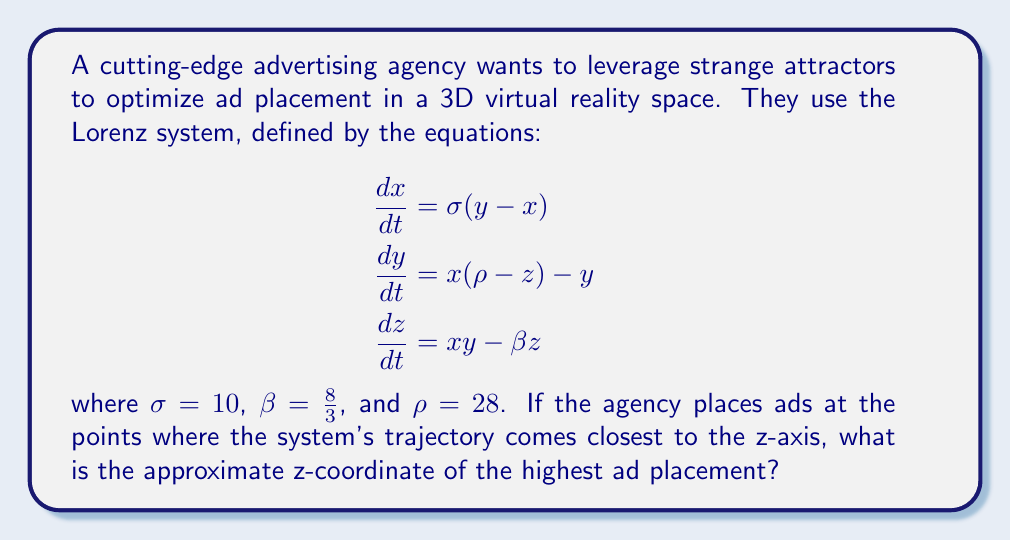What is the answer to this math problem? To solve this problem, we need to understand the behavior of the Lorenz attractor and identify its key features:

1. The Lorenz system with the given parameters produces a strange attractor known as the Lorenz attractor.

2. The attractor has a distinctive butterfly-like shape with two lobes.

3. The points where the trajectory comes closest to the z-axis are near the centers of these lobes.

4. To find the highest ad placement, we need to determine the z-coordinate of the upper lobe's center.

5. The z-coordinates of the lobe centers can be approximated using the following formula:

   $$z = \pm \sqrt{\beta(\rho - 1)}$$

6. Substituting the given values:
   
   $$z = \pm \sqrt{\frac{8}{3}(28 - 1)} = \pm \sqrt{\frac{8}{3} \cdot 27} = \pm \sqrt{72} = \pm 6\sqrt{2}$$

7. The positive value represents the upper lobe's center, which is where the highest ad would be placed.

8. $6\sqrt{2} \approx 8.49$

Therefore, the approximate z-coordinate of the highest ad placement is 8.49.
Answer: 8.49 